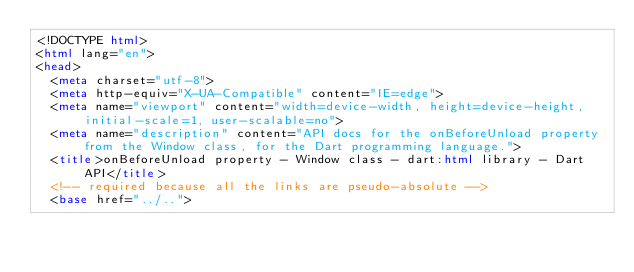Convert code to text. <code><loc_0><loc_0><loc_500><loc_500><_HTML_><!DOCTYPE html>
<html lang="en">
<head>
  <meta charset="utf-8">
  <meta http-equiv="X-UA-Compatible" content="IE=edge">
  <meta name="viewport" content="width=device-width, height=device-height, initial-scale=1, user-scalable=no">
  <meta name="description" content="API docs for the onBeforeUnload property from the Window class, for the Dart programming language.">
  <title>onBeforeUnload property - Window class - dart:html library - Dart API</title>
  <!-- required because all the links are pseudo-absolute -->
  <base href="../..">
</code> 